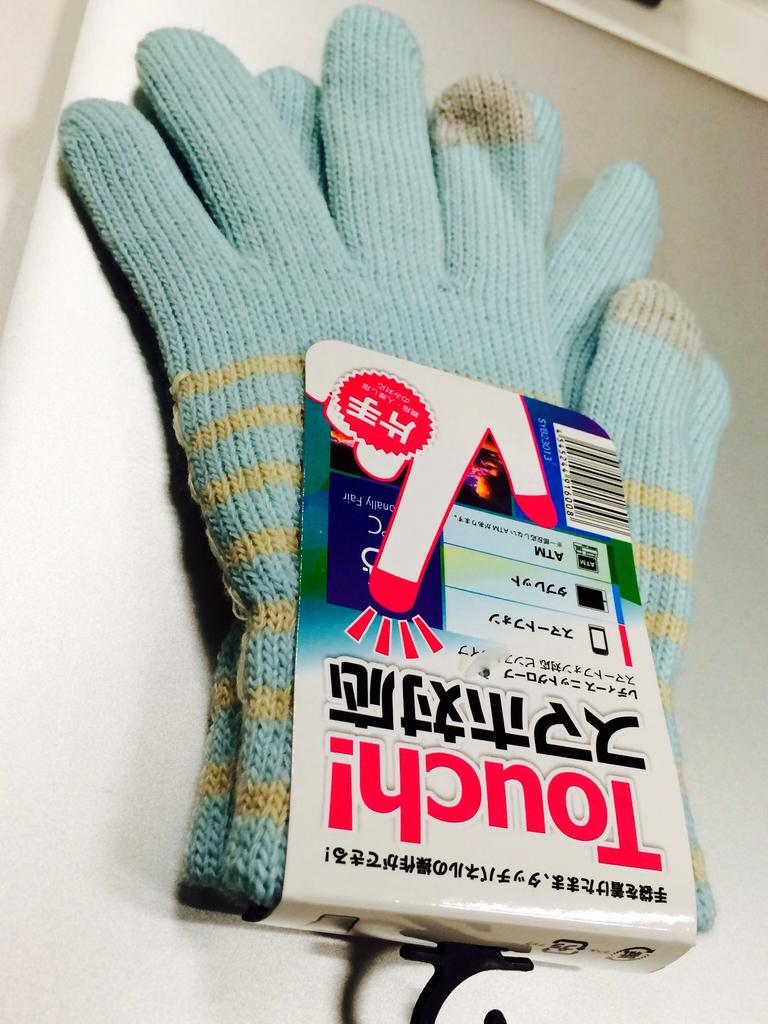What type of gloves can be seen in the image? There are woolen gloves in the image. What type of shame can be seen on the gloves in the image? There is no shame present on the gloves in the image; they are simply woolen gloves. How many bikes are visible in the image? There are no bikes present in the image; it only features woolen gloves. 